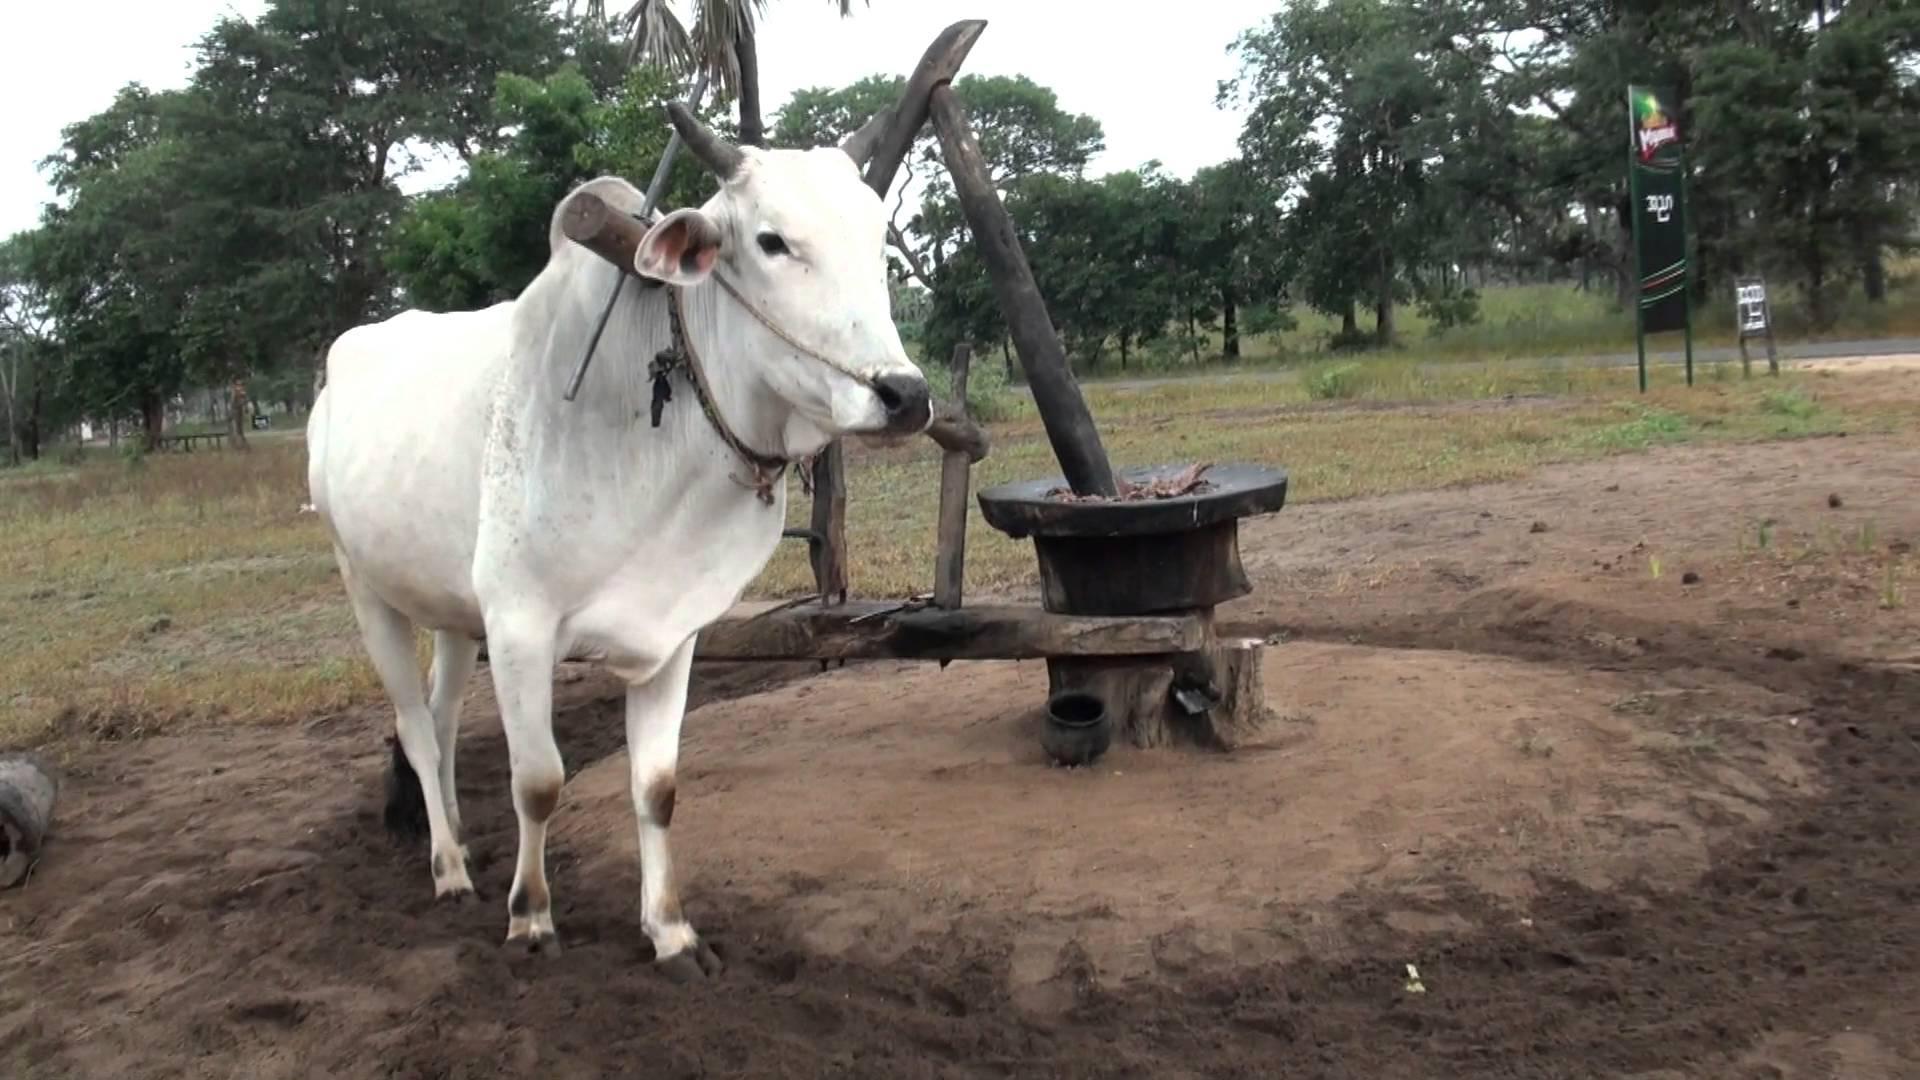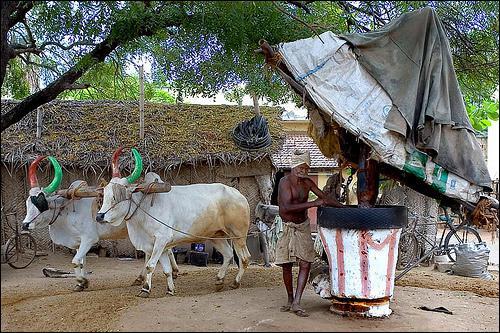The first image is the image on the left, the second image is the image on the right. Evaluate the accuracy of this statement regarding the images: "There is a green bowl under a spout that comes out from the mill in the left image.". Is it true? Answer yes or no. No. The first image is the image on the left, the second image is the image on the right. For the images displayed, is the sentence "The man attending the cow in one of the photos is shirtless." factually correct? Answer yes or no. Yes. 